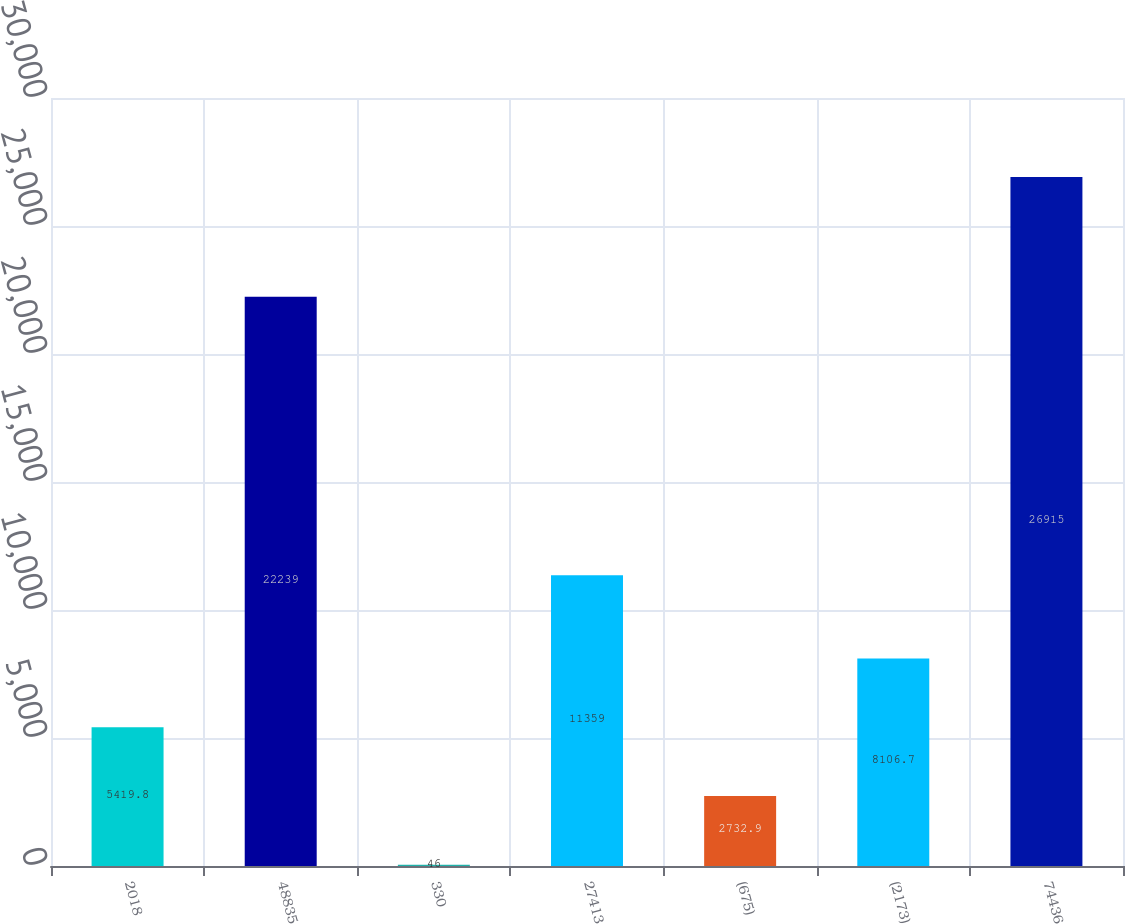<chart> <loc_0><loc_0><loc_500><loc_500><bar_chart><fcel>2018<fcel>48835<fcel>330<fcel>27413<fcel>(675)<fcel>(2173)<fcel>74436<nl><fcel>5419.8<fcel>22239<fcel>46<fcel>11359<fcel>2732.9<fcel>8106.7<fcel>26915<nl></chart> 